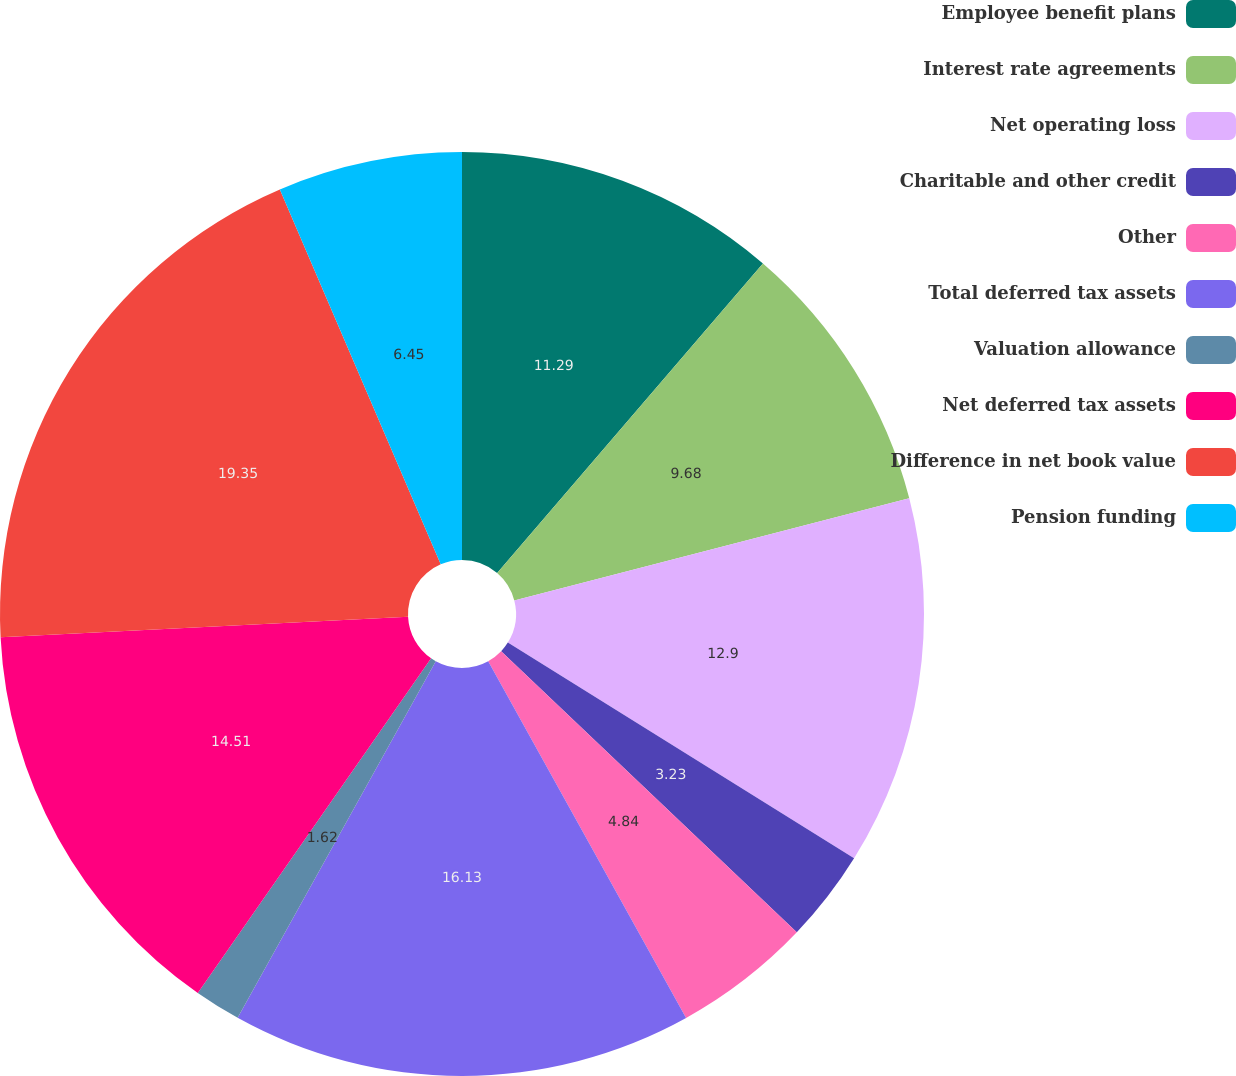<chart> <loc_0><loc_0><loc_500><loc_500><pie_chart><fcel>Employee benefit plans<fcel>Interest rate agreements<fcel>Net operating loss<fcel>Charitable and other credit<fcel>Other<fcel>Total deferred tax assets<fcel>Valuation allowance<fcel>Net deferred tax assets<fcel>Difference in net book value<fcel>Pension funding<nl><fcel>11.29%<fcel>9.68%<fcel>12.9%<fcel>3.23%<fcel>4.84%<fcel>16.13%<fcel>1.62%<fcel>14.51%<fcel>19.35%<fcel>6.45%<nl></chart> 